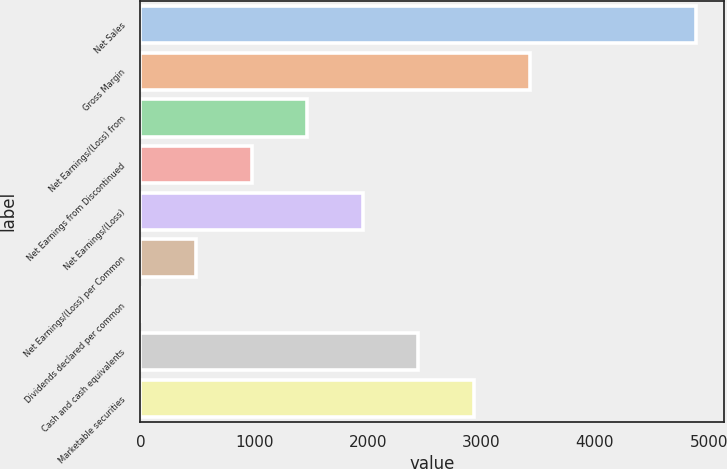<chart> <loc_0><loc_0><loc_500><loc_500><bar_chart><fcel>Net Sales<fcel>Gross Margin<fcel>Net Earnings/(Loss) from<fcel>Net Earnings from Discontinued<fcel>Net Earnings/(Loss)<fcel>Net Earnings/(Loss) per Common<fcel>Dividends declared per common<fcel>Cash and cash equivalents<fcel>Marketable securities<nl><fcel>4893<fcel>3425.17<fcel>1468.09<fcel>978.82<fcel>1957.36<fcel>489.55<fcel>0.28<fcel>2446.63<fcel>2935.9<nl></chart> 